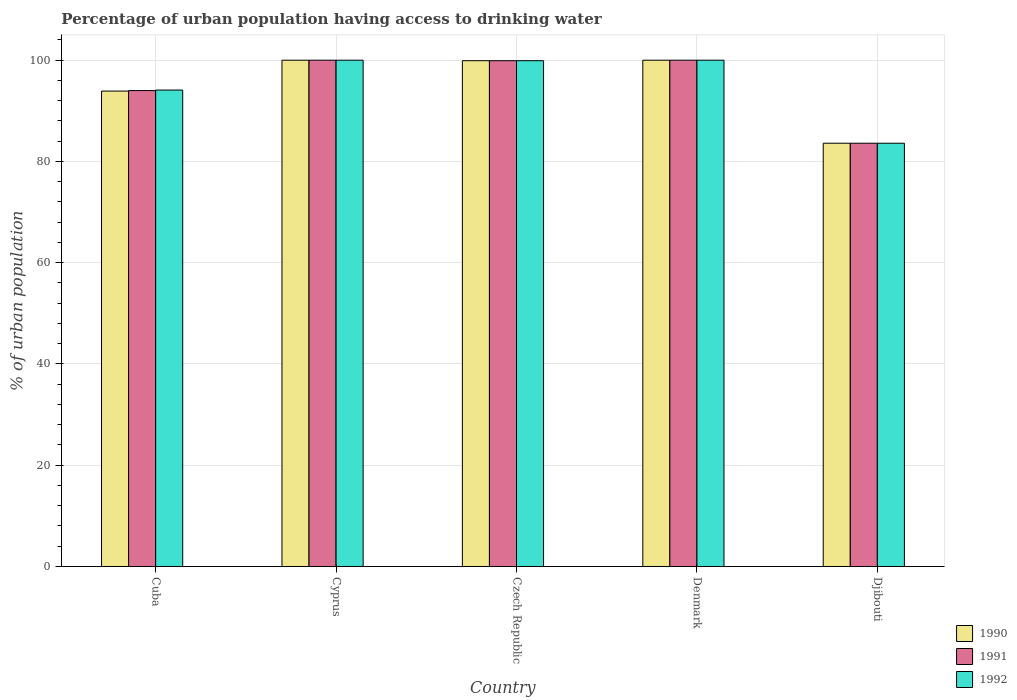How many different coloured bars are there?
Provide a succinct answer. 3. How many groups of bars are there?
Provide a succinct answer. 5. How many bars are there on the 2nd tick from the left?
Provide a short and direct response. 3. What is the label of the 1st group of bars from the left?
Your response must be concise. Cuba. What is the percentage of urban population having access to drinking water in 1992 in Denmark?
Offer a terse response. 100. Across all countries, what is the minimum percentage of urban population having access to drinking water in 1991?
Keep it short and to the point. 83.6. In which country was the percentage of urban population having access to drinking water in 1990 maximum?
Provide a succinct answer. Cyprus. In which country was the percentage of urban population having access to drinking water in 1990 minimum?
Provide a short and direct response. Djibouti. What is the total percentage of urban population having access to drinking water in 1992 in the graph?
Provide a succinct answer. 477.6. What is the difference between the percentage of urban population having access to drinking water in 1992 in Cuba and that in Cyprus?
Keep it short and to the point. -5.9. What is the difference between the percentage of urban population having access to drinking water in 1990 in Denmark and the percentage of urban population having access to drinking water in 1992 in Cuba?
Provide a succinct answer. 5.9. What is the average percentage of urban population having access to drinking water in 1992 per country?
Ensure brevity in your answer.  95.52. What is the difference between the percentage of urban population having access to drinking water of/in 1991 and percentage of urban population having access to drinking water of/in 1990 in Djibouti?
Make the answer very short. 0. What is the ratio of the percentage of urban population having access to drinking water in 1992 in Cyprus to that in Djibouti?
Offer a very short reply. 1.2. Is the percentage of urban population having access to drinking water in 1991 in Cuba less than that in Cyprus?
Give a very brief answer. Yes. Is the difference between the percentage of urban population having access to drinking water in 1991 in Cyprus and Czech Republic greater than the difference between the percentage of urban population having access to drinking water in 1990 in Cyprus and Czech Republic?
Your answer should be compact. No. What is the difference between the highest and the second highest percentage of urban population having access to drinking water in 1990?
Provide a short and direct response. -0.1. What is the difference between the highest and the lowest percentage of urban population having access to drinking water in 1991?
Give a very brief answer. 16.4. In how many countries, is the percentage of urban population having access to drinking water in 1991 greater than the average percentage of urban population having access to drinking water in 1991 taken over all countries?
Your answer should be very brief. 3. What does the 1st bar from the right in Czech Republic represents?
Provide a succinct answer. 1992. How many bars are there?
Give a very brief answer. 15. Are all the bars in the graph horizontal?
Give a very brief answer. No. How many countries are there in the graph?
Your answer should be compact. 5. What is the difference between two consecutive major ticks on the Y-axis?
Your response must be concise. 20. Does the graph contain any zero values?
Keep it short and to the point. No. Where does the legend appear in the graph?
Your answer should be compact. Bottom right. How many legend labels are there?
Provide a short and direct response. 3. How are the legend labels stacked?
Provide a succinct answer. Vertical. What is the title of the graph?
Your answer should be compact. Percentage of urban population having access to drinking water. What is the label or title of the Y-axis?
Offer a very short reply. % of urban population. What is the % of urban population of 1990 in Cuba?
Offer a terse response. 93.9. What is the % of urban population of 1991 in Cuba?
Your answer should be compact. 94. What is the % of urban population of 1992 in Cuba?
Your response must be concise. 94.1. What is the % of urban population of 1991 in Cyprus?
Make the answer very short. 100. What is the % of urban population in 1992 in Cyprus?
Provide a succinct answer. 100. What is the % of urban population of 1990 in Czech Republic?
Your response must be concise. 99.9. What is the % of urban population of 1991 in Czech Republic?
Keep it short and to the point. 99.9. What is the % of urban population of 1992 in Czech Republic?
Keep it short and to the point. 99.9. What is the % of urban population in 1990 in Denmark?
Your answer should be very brief. 100. What is the % of urban population of 1992 in Denmark?
Give a very brief answer. 100. What is the % of urban population in 1990 in Djibouti?
Keep it short and to the point. 83.6. What is the % of urban population in 1991 in Djibouti?
Your response must be concise. 83.6. What is the % of urban population of 1992 in Djibouti?
Offer a terse response. 83.6. Across all countries, what is the maximum % of urban population in 1992?
Provide a short and direct response. 100. Across all countries, what is the minimum % of urban population of 1990?
Make the answer very short. 83.6. Across all countries, what is the minimum % of urban population of 1991?
Your answer should be compact. 83.6. Across all countries, what is the minimum % of urban population in 1992?
Give a very brief answer. 83.6. What is the total % of urban population in 1990 in the graph?
Provide a succinct answer. 477.4. What is the total % of urban population of 1991 in the graph?
Keep it short and to the point. 477.5. What is the total % of urban population in 1992 in the graph?
Your response must be concise. 477.6. What is the difference between the % of urban population of 1991 in Cuba and that in Czech Republic?
Give a very brief answer. -5.9. What is the difference between the % of urban population in 1990 in Cuba and that in Djibouti?
Offer a very short reply. 10.3. What is the difference between the % of urban population of 1991 in Cuba and that in Djibouti?
Provide a succinct answer. 10.4. What is the difference between the % of urban population of 1990 in Cyprus and that in Czech Republic?
Ensure brevity in your answer.  0.1. What is the difference between the % of urban population of 1991 in Cyprus and that in Czech Republic?
Your answer should be compact. 0.1. What is the difference between the % of urban population in 1990 in Cyprus and that in Denmark?
Keep it short and to the point. 0. What is the difference between the % of urban population of 1990 in Cyprus and that in Djibouti?
Provide a short and direct response. 16.4. What is the difference between the % of urban population of 1992 in Cyprus and that in Djibouti?
Make the answer very short. 16.4. What is the difference between the % of urban population of 1992 in Czech Republic and that in Denmark?
Offer a terse response. -0.1. What is the difference between the % of urban population in 1990 in Czech Republic and that in Djibouti?
Your response must be concise. 16.3. What is the difference between the % of urban population in 1990 in Denmark and that in Djibouti?
Your answer should be compact. 16.4. What is the difference between the % of urban population of 1990 in Cuba and the % of urban population of 1992 in Cyprus?
Provide a short and direct response. -6.1. What is the difference between the % of urban population of 1991 in Cuba and the % of urban population of 1992 in Cyprus?
Ensure brevity in your answer.  -6. What is the difference between the % of urban population in 1990 in Cuba and the % of urban population in 1992 in Czech Republic?
Provide a succinct answer. -6. What is the difference between the % of urban population in 1991 in Cuba and the % of urban population in 1992 in Djibouti?
Ensure brevity in your answer.  10.4. What is the difference between the % of urban population in 1990 in Cyprus and the % of urban population in 1992 in Czech Republic?
Your response must be concise. 0.1. What is the difference between the % of urban population in 1991 in Cyprus and the % of urban population in 1992 in Czech Republic?
Provide a short and direct response. 0.1. What is the difference between the % of urban population of 1990 in Cyprus and the % of urban population of 1991 in Denmark?
Keep it short and to the point. 0. What is the difference between the % of urban population in 1990 in Cyprus and the % of urban population in 1991 in Djibouti?
Ensure brevity in your answer.  16.4. What is the difference between the % of urban population of 1990 in Cyprus and the % of urban population of 1992 in Djibouti?
Keep it short and to the point. 16.4. What is the difference between the % of urban population of 1991 in Cyprus and the % of urban population of 1992 in Djibouti?
Keep it short and to the point. 16.4. What is the difference between the % of urban population of 1990 in Czech Republic and the % of urban population of 1991 in Denmark?
Your response must be concise. -0.1. What is the difference between the % of urban population in 1991 in Czech Republic and the % of urban population in 1992 in Denmark?
Offer a terse response. -0.1. What is the difference between the % of urban population in 1991 in Denmark and the % of urban population in 1992 in Djibouti?
Provide a short and direct response. 16.4. What is the average % of urban population in 1990 per country?
Offer a terse response. 95.48. What is the average % of urban population of 1991 per country?
Provide a succinct answer. 95.5. What is the average % of urban population in 1992 per country?
Give a very brief answer. 95.52. What is the difference between the % of urban population in 1991 and % of urban population in 1992 in Cuba?
Ensure brevity in your answer.  -0.1. What is the difference between the % of urban population in 1991 and % of urban population in 1992 in Denmark?
Give a very brief answer. 0. What is the difference between the % of urban population in 1990 and % of urban population in 1991 in Djibouti?
Your answer should be compact. 0. What is the difference between the % of urban population of 1990 and % of urban population of 1992 in Djibouti?
Your answer should be compact. 0. What is the ratio of the % of urban population in 1990 in Cuba to that in Cyprus?
Your response must be concise. 0.94. What is the ratio of the % of urban population in 1992 in Cuba to that in Cyprus?
Your response must be concise. 0.94. What is the ratio of the % of urban population in 1990 in Cuba to that in Czech Republic?
Your response must be concise. 0.94. What is the ratio of the % of urban population of 1991 in Cuba to that in Czech Republic?
Provide a short and direct response. 0.94. What is the ratio of the % of urban population of 1992 in Cuba to that in Czech Republic?
Offer a very short reply. 0.94. What is the ratio of the % of urban population in 1990 in Cuba to that in Denmark?
Ensure brevity in your answer.  0.94. What is the ratio of the % of urban population in 1991 in Cuba to that in Denmark?
Offer a very short reply. 0.94. What is the ratio of the % of urban population in 1992 in Cuba to that in Denmark?
Ensure brevity in your answer.  0.94. What is the ratio of the % of urban population of 1990 in Cuba to that in Djibouti?
Ensure brevity in your answer.  1.12. What is the ratio of the % of urban population in 1991 in Cuba to that in Djibouti?
Your response must be concise. 1.12. What is the ratio of the % of urban population in 1992 in Cuba to that in Djibouti?
Provide a short and direct response. 1.13. What is the ratio of the % of urban population of 1992 in Cyprus to that in Czech Republic?
Your answer should be compact. 1. What is the ratio of the % of urban population in 1990 in Cyprus to that in Djibouti?
Offer a terse response. 1.2. What is the ratio of the % of urban population of 1991 in Cyprus to that in Djibouti?
Provide a short and direct response. 1.2. What is the ratio of the % of urban population of 1992 in Cyprus to that in Djibouti?
Offer a terse response. 1.2. What is the ratio of the % of urban population of 1990 in Czech Republic to that in Denmark?
Your answer should be very brief. 1. What is the ratio of the % of urban population in 1991 in Czech Republic to that in Denmark?
Make the answer very short. 1. What is the ratio of the % of urban population of 1990 in Czech Republic to that in Djibouti?
Offer a very short reply. 1.2. What is the ratio of the % of urban population of 1991 in Czech Republic to that in Djibouti?
Offer a very short reply. 1.2. What is the ratio of the % of urban population in 1992 in Czech Republic to that in Djibouti?
Keep it short and to the point. 1.2. What is the ratio of the % of urban population of 1990 in Denmark to that in Djibouti?
Your answer should be compact. 1.2. What is the ratio of the % of urban population in 1991 in Denmark to that in Djibouti?
Offer a terse response. 1.2. What is the ratio of the % of urban population in 1992 in Denmark to that in Djibouti?
Provide a short and direct response. 1.2. What is the difference between the highest and the second highest % of urban population in 1991?
Make the answer very short. 0. What is the difference between the highest and the lowest % of urban population in 1991?
Your answer should be very brief. 16.4. What is the difference between the highest and the lowest % of urban population of 1992?
Your answer should be very brief. 16.4. 